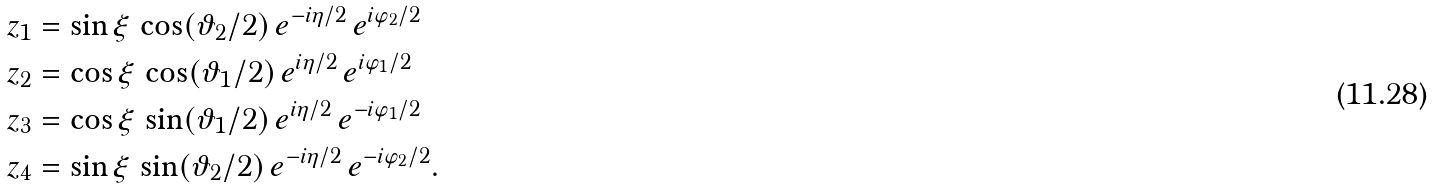<formula> <loc_0><loc_0><loc_500><loc_500>z _ { 1 } & = \sin \xi \, \cos ( \vartheta _ { 2 } / 2 ) \, e ^ { - i \eta / 2 } \, e ^ { i \varphi _ { 2 } / 2 } \\ z _ { 2 } & = \cos \xi \, \cos ( \vartheta _ { 1 } / 2 ) \, e ^ { i \eta / 2 } \, e ^ { i \varphi _ { 1 } / 2 } \\ z _ { 3 } & = \cos \xi \, \sin ( \vartheta _ { 1 } / 2 ) \, e ^ { i \eta / 2 } \, e ^ { - i \varphi _ { 1 } / 2 } \\ z _ { 4 } & = \sin \xi \, \sin ( \vartheta _ { 2 } / 2 ) \, e ^ { - i \eta / 2 } \, e ^ { - i \varphi _ { 2 } / 2 } .</formula> 